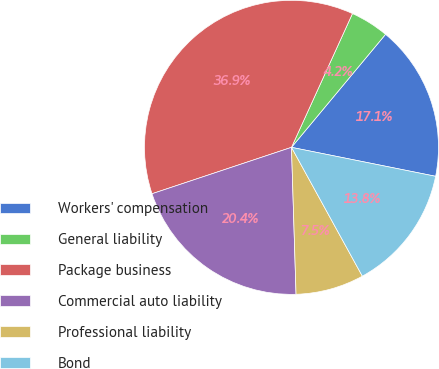<chart> <loc_0><loc_0><loc_500><loc_500><pie_chart><fcel>Workers' compensation<fcel>General liability<fcel>Package business<fcel>Commercial auto liability<fcel>Professional liability<fcel>Bond<nl><fcel>17.11%<fcel>4.24%<fcel>36.92%<fcel>20.38%<fcel>7.51%<fcel>13.84%<nl></chart> 